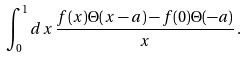Convert formula to latex. <formula><loc_0><loc_0><loc_500><loc_500>\int _ { 0 } ^ { 1 } d x \, \frac { f ( x ) \Theta ( x - a ) - f ( 0 ) \Theta ( - a ) } { x } \, .</formula> 